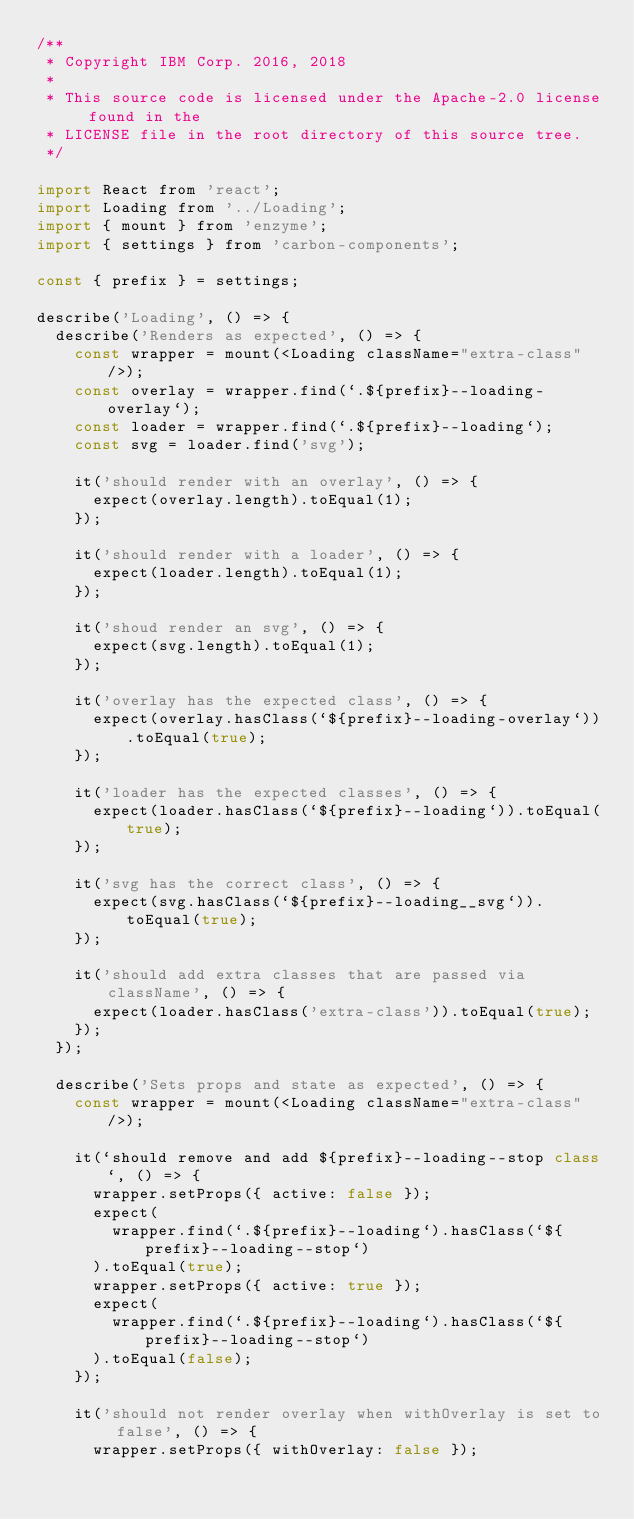Convert code to text. <code><loc_0><loc_0><loc_500><loc_500><_JavaScript_>/**
 * Copyright IBM Corp. 2016, 2018
 *
 * This source code is licensed under the Apache-2.0 license found in the
 * LICENSE file in the root directory of this source tree.
 */

import React from 'react';
import Loading from '../Loading';
import { mount } from 'enzyme';
import { settings } from 'carbon-components';

const { prefix } = settings;

describe('Loading', () => {
  describe('Renders as expected', () => {
    const wrapper = mount(<Loading className="extra-class" />);
    const overlay = wrapper.find(`.${prefix}--loading-overlay`);
    const loader = wrapper.find(`.${prefix}--loading`);
    const svg = loader.find('svg');

    it('should render with an overlay', () => {
      expect(overlay.length).toEqual(1);
    });

    it('should render with a loader', () => {
      expect(loader.length).toEqual(1);
    });

    it('shoud render an svg', () => {
      expect(svg.length).toEqual(1);
    });

    it('overlay has the expected class', () => {
      expect(overlay.hasClass(`${prefix}--loading-overlay`)).toEqual(true);
    });

    it('loader has the expected classes', () => {
      expect(loader.hasClass(`${prefix}--loading`)).toEqual(true);
    });

    it('svg has the correct class', () => {
      expect(svg.hasClass(`${prefix}--loading__svg`)).toEqual(true);
    });

    it('should add extra classes that are passed via className', () => {
      expect(loader.hasClass('extra-class')).toEqual(true);
    });
  });

  describe('Sets props and state as expected', () => {
    const wrapper = mount(<Loading className="extra-class" />);

    it(`should remove and add ${prefix}--loading--stop class`, () => {
      wrapper.setProps({ active: false });
      expect(
        wrapper.find(`.${prefix}--loading`).hasClass(`${prefix}--loading--stop`)
      ).toEqual(true);
      wrapper.setProps({ active: true });
      expect(
        wrapper.find(`.${prefix}--loading`).hasClass(`${prefix}--loading--stop`)
      ).toEqual(false);
    });

    it('should not render overlay when withOverlay is set to false', () => {
      wrapper.setProps({ withOverlay: false });</code> 